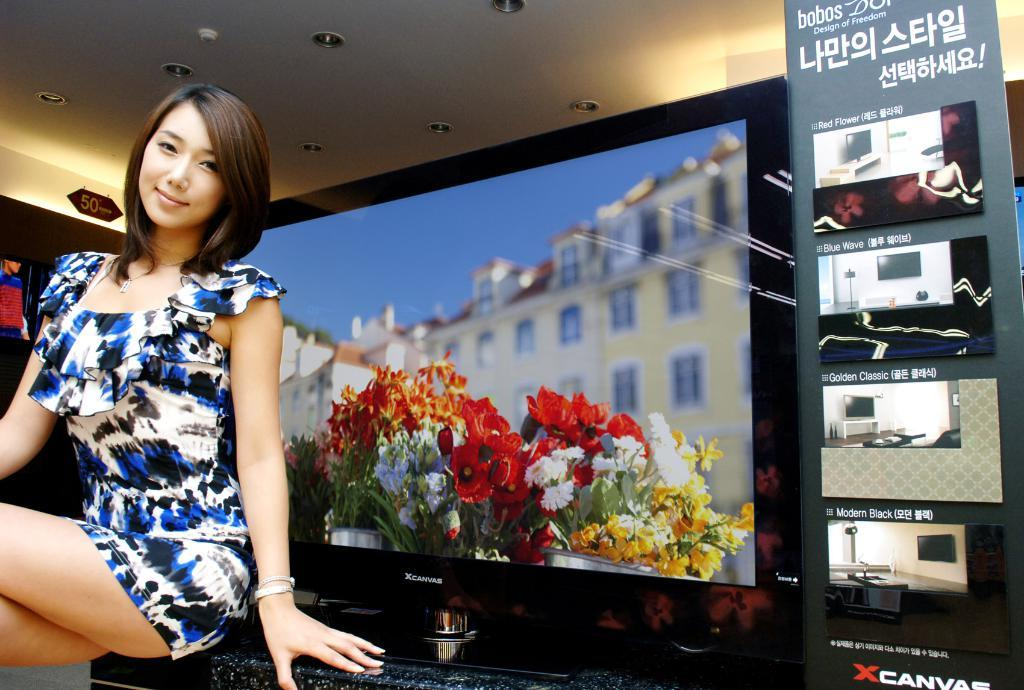<image>
Relay a brief, clear account of the picture shown. A woman sits in front of an XCanvas television that comes in different colors including Red Flower, Blue Wave, Golden Classic, and Modern Black. 